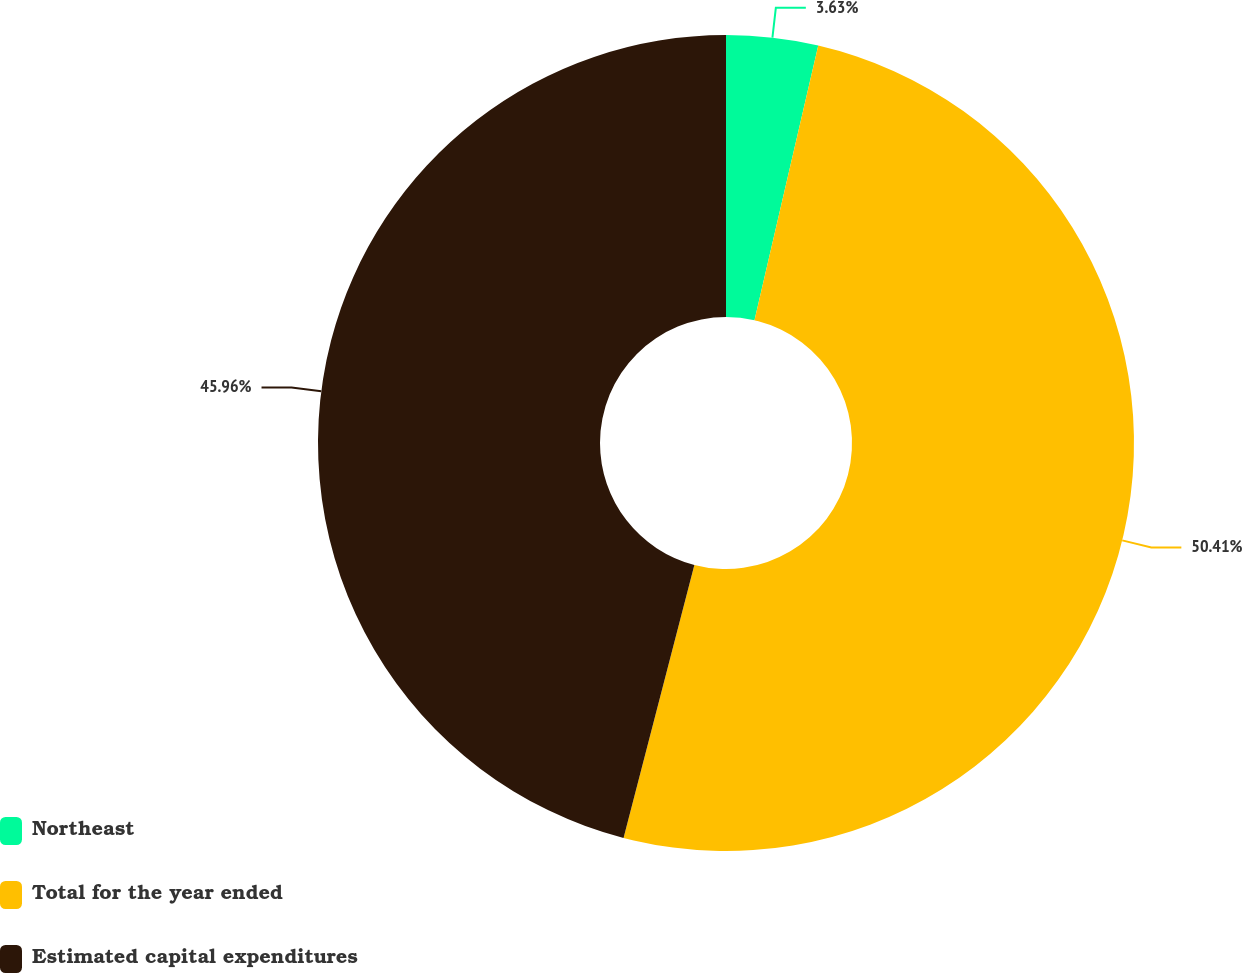<chart> <loc_0><loc_0><loc_500><loc_500><pie_chart><fcel>Northeast<fcel>Total for the year ended<fcel>Estimated capital expenditures<nl><fcel>3.63%<fcel>50.41%<fcel>45.96%<nl></chart> 